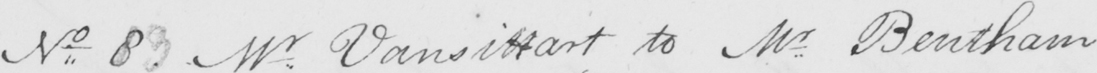What does this handwritten line say? No 83 Mr . Vansittart to Mr Bentham 